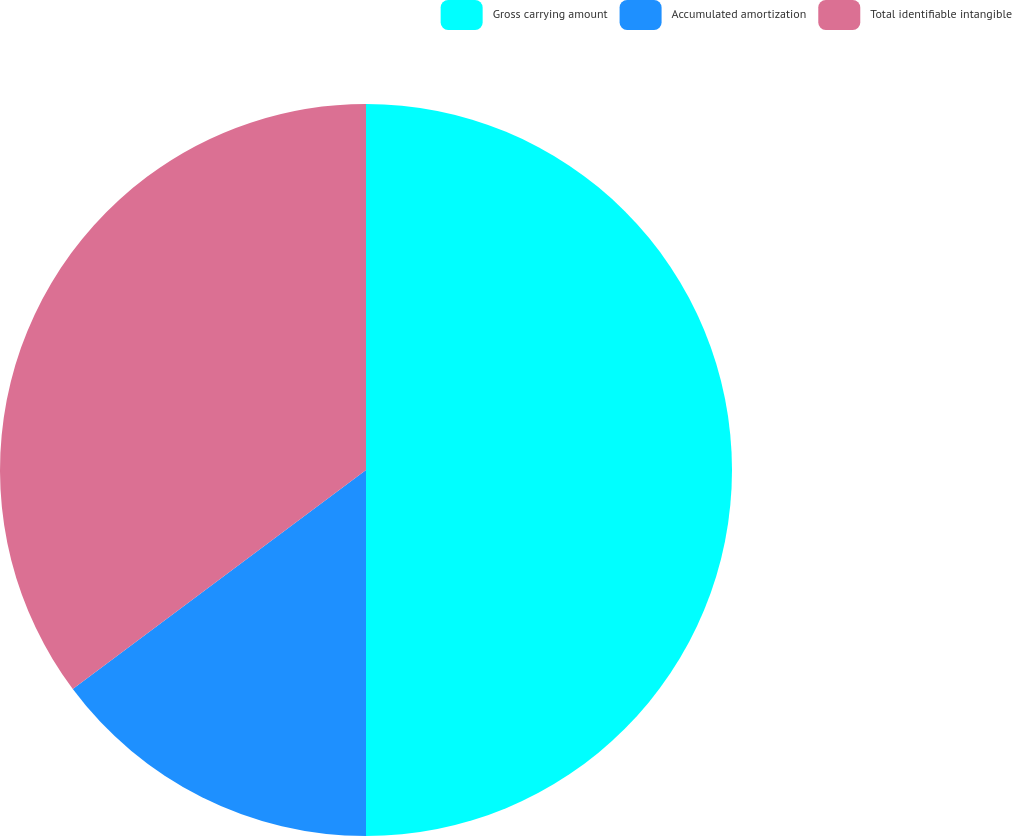Convert chart to OTSL. <chart><loc_0><loc_0><loc_500><loc_500><pie_chart><fcel>Gross carrying amount<fcel>Accumulated amortization<fcel>Total identifiable intangible<nl><fcel>50.0%<fcel>14.79%<fcel>35.21%<nl></chart> 